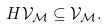Convert formula to latex. <formula><loc_0><loc_0><loc_500><loc_500>H { \mathcal { V } } _ { \mathcal { M } } \subseteq { \mathcal { V } } _ { \mathcal { M } } .</formula> 